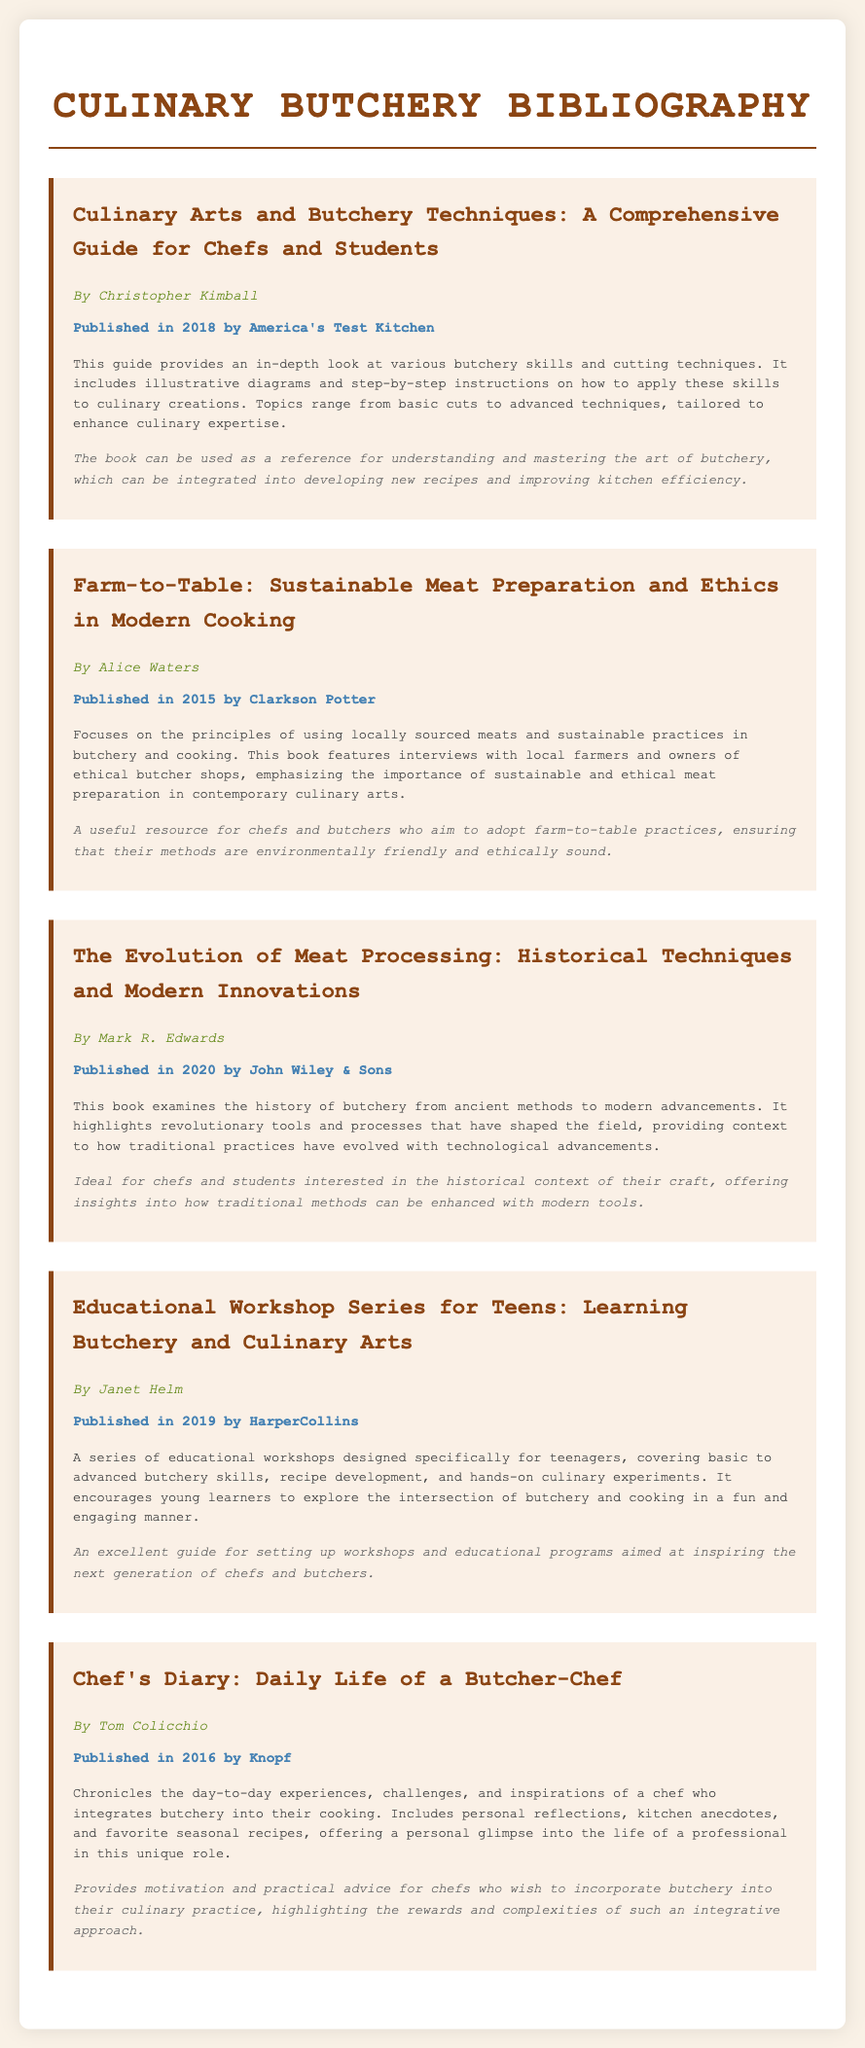What is the title of the first book? The title of the first book is listed at the beginning of its entry in the document.
Answer: Culinary Arts and Butchery Techniques: A Comprehensive Guide for Chefs and Students Who is the author of "Farm-to-Table"? The author is mentioned directly under the title in the corresponding book section.
Answer: Alice Waters What year was "The Evolution of Meat Processing" published? The publication year is indicated near the author's name in each book section.
Answer: 2020 What is the focus of "Educational Workshop Series for Teens"? The summary provides insight into the main subject of this book.
Answer: Learning Butchery and Culinary Arts Which book emphasizes sustainable practices in butchery? The summary discusses the themes and priorities of each book, including sustainability.
Answer: Farm-to-Table: Sustainable Meat Preparation and Ethics in Modern Cooking How many books are listed in this bibliography? By counting the book entries presented, one can determine the total.
Answer: Five What type of resource is "Chef's Diary"? The nature of the book is described in its summary and application sections.
Answer: Personal reflections and anecdotes What is a common theme among the books listed? Analyzing the summaries will reveal recurring concepts across the entries.
Answer: Butchery and Culinary Integration 